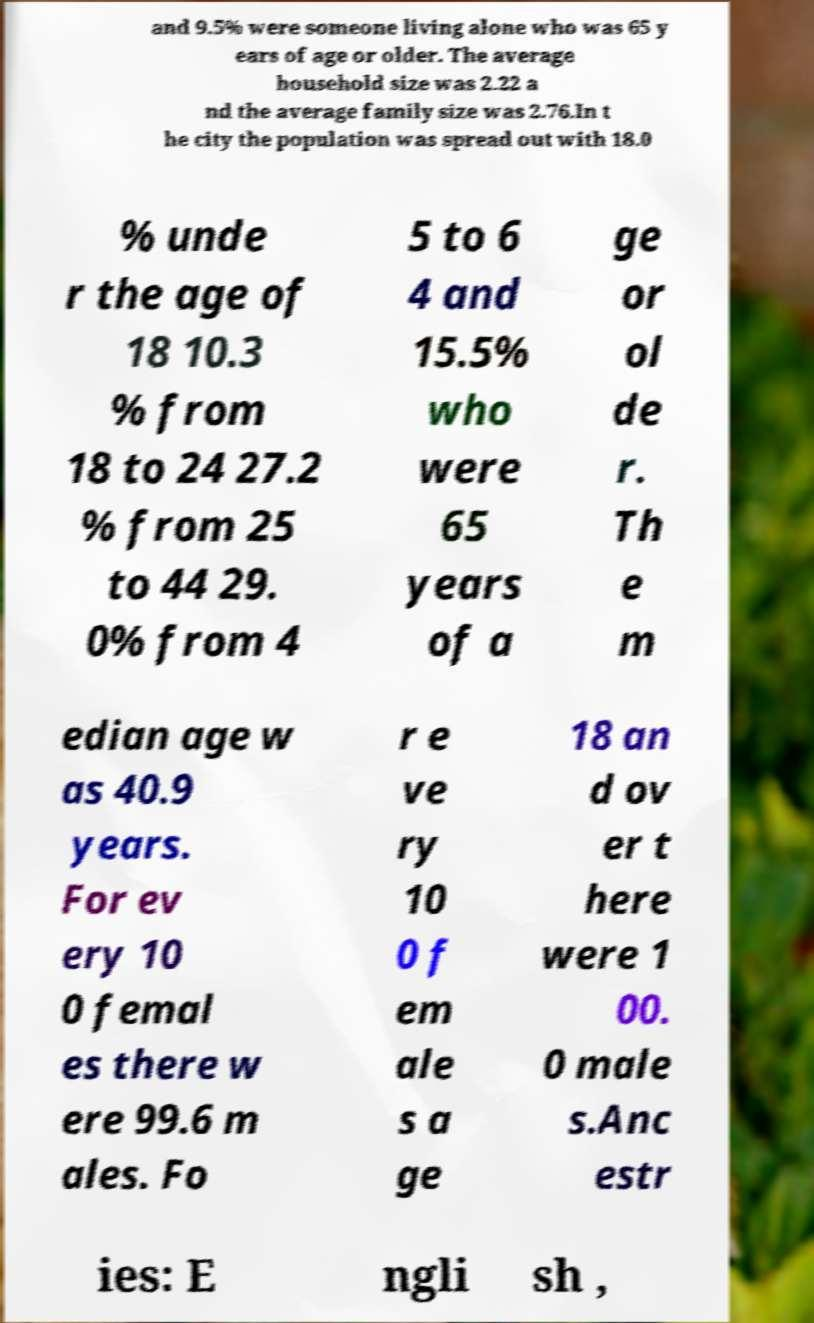I need the written content from this picture converted into text. Can you do that? and 9.5% were someone living alone who was 65 y ears of age or older. The average household size was 2.22 a nd the average family size was 2.76.In t he city the population was spread out with 18.0 % unde r the age of 18 10.3 % from 18 to 24 27.2 % from 25 to 44 29. 0% from 4 5 to 6 4 and 15.5% who were 65 years of a ge or ol de r. Th e m edian age w as 40.9 years. For ev ery 10 0 femal es there w ere 99.6 m ales. Fo r e ve ry 10 0 f em ale s a ge 18 an d ov er t here were 1 00. 0 male s.Anc estr ies: E ngli sh , 